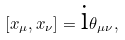Convert formula to latex. <formula><loc_0><loc_0><loc_500><loc_500>\left [ x _ { \mu } , x _ { \nu } \right ] = \text {i} \theta _ { \mu \nu } ,</formula> 